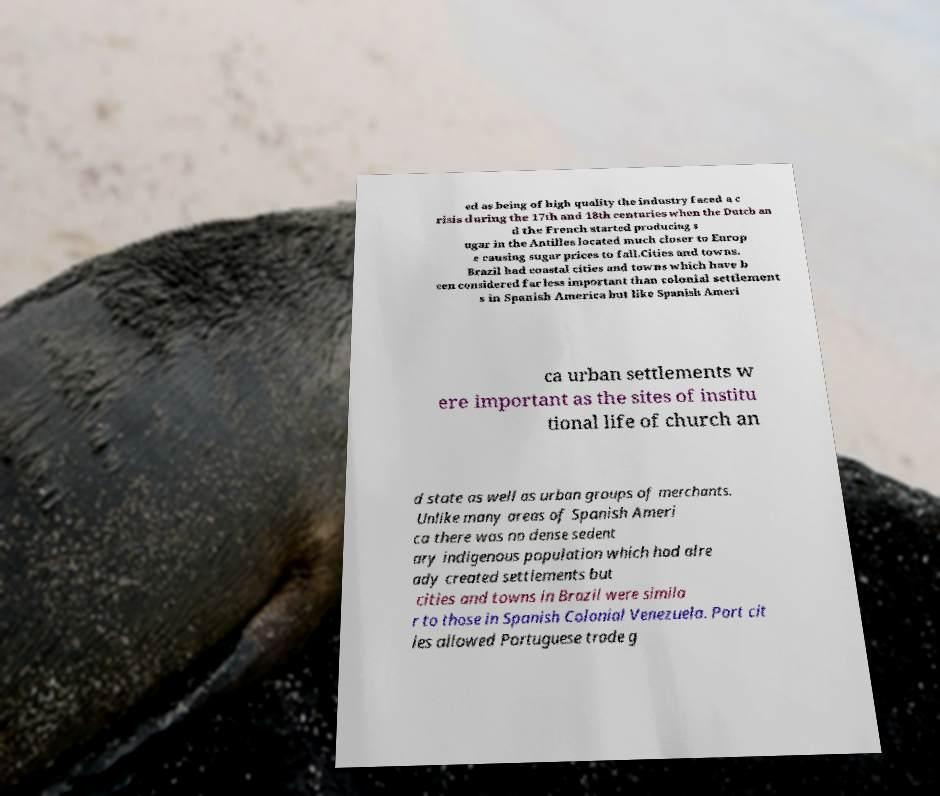Please read and relay the text visible in this image. What does it say? ed as being of high quality the industry faced a c risis during the 17th and 18th centuries when the Dutch an d the French started producing s ugar in the Antilles located much closer to Europ e causing sugar prices to fall.Cities and towns. Brazil had coastal cities and towns which have b een considered far less important than colonial settlement s in Spanish America but like Spanish Ameri ca urban settlements w ere important as the sites of institu tional life of church an d state as well as urban groups of merchants. Unlike many areas of Spanish Ameri ca there was no dense sedent ary indigenous population which had alre ady created settlements but cities and towns in Brazil were simila r to those in Spanish Colonial Venezuela. Port cit ies allowed Portuguese trade g 